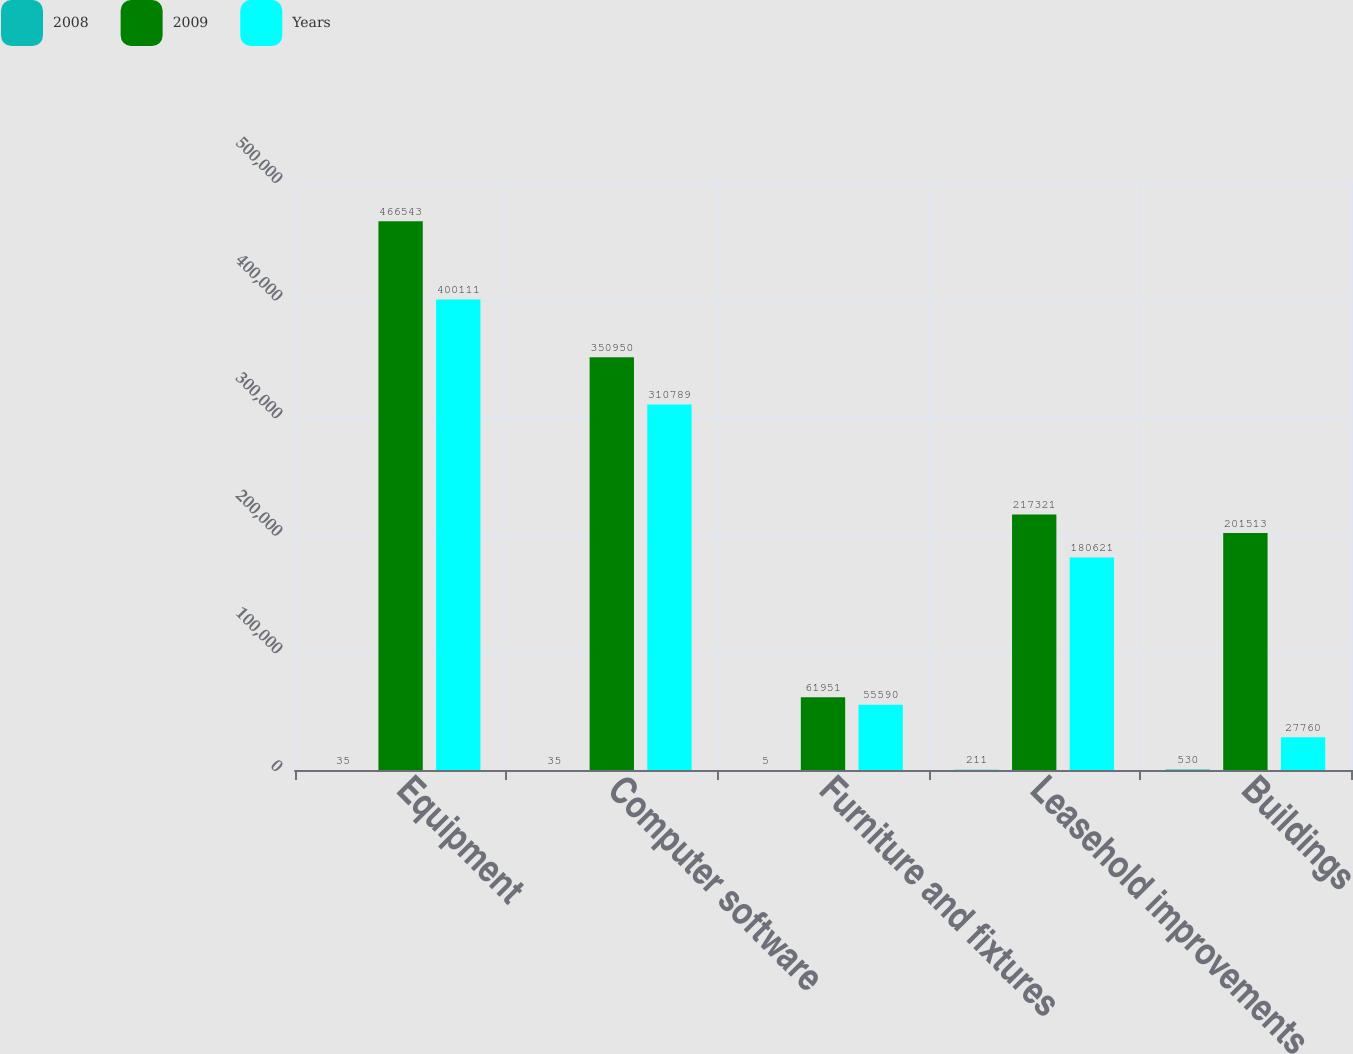<chart> <loc_0><loc_0><loc_500><loc_500><stacked_bar_chart><ecel><fcel>Equipment<fcel>Computer software<fcel>Furniture and fixtures<fcel>Leasehold improvements<fcel>Buildings<nl><fcel>2008<fcel>35<fcel>35<fcel>5<fcel>211<fcel>530<nl><fcel>2009<fcel>466543<fcel>350950<fcel>61951<fcel>217321<fcel>201513<nl><fcel>Years<fcel>400111<fcel>310789<fcel>55590<fcel>180621<fcel>27760<nl></chart> 